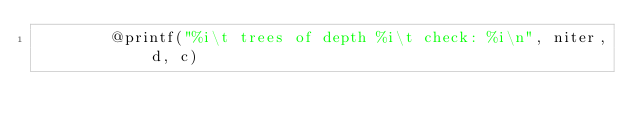Convert code to text. <code><loc_0><loc_0><loc_500><loc_500><_Julia_>        @printf("%i\t trees of depth %i\t check: %i\n", niter, d, c)</code> 